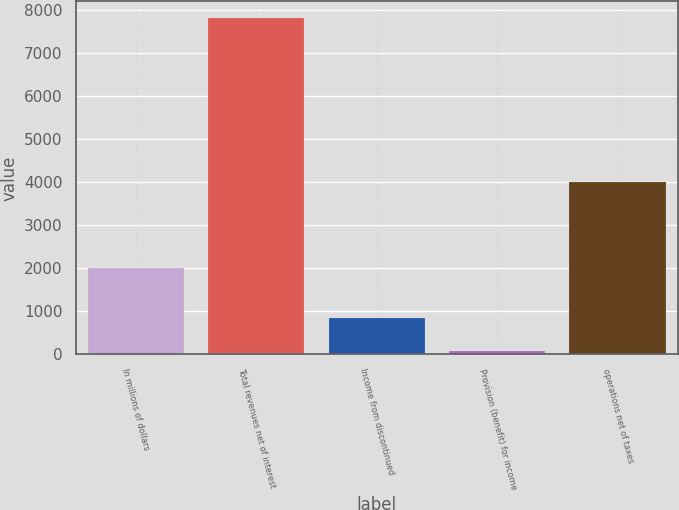<chart> <loc_0><loc_0><loc_500><loc_500><bar_chart><fcel>In millions of dollars<fcel>Total revenues net of interest<fcel>Income from discontinued<fcel>Provision (benefit) for income<fcel>operations net of taxes<nl><fcel>2008<fcel>7810<fcel>852.1<fcel>79<fcel>4002<nl></chart> 